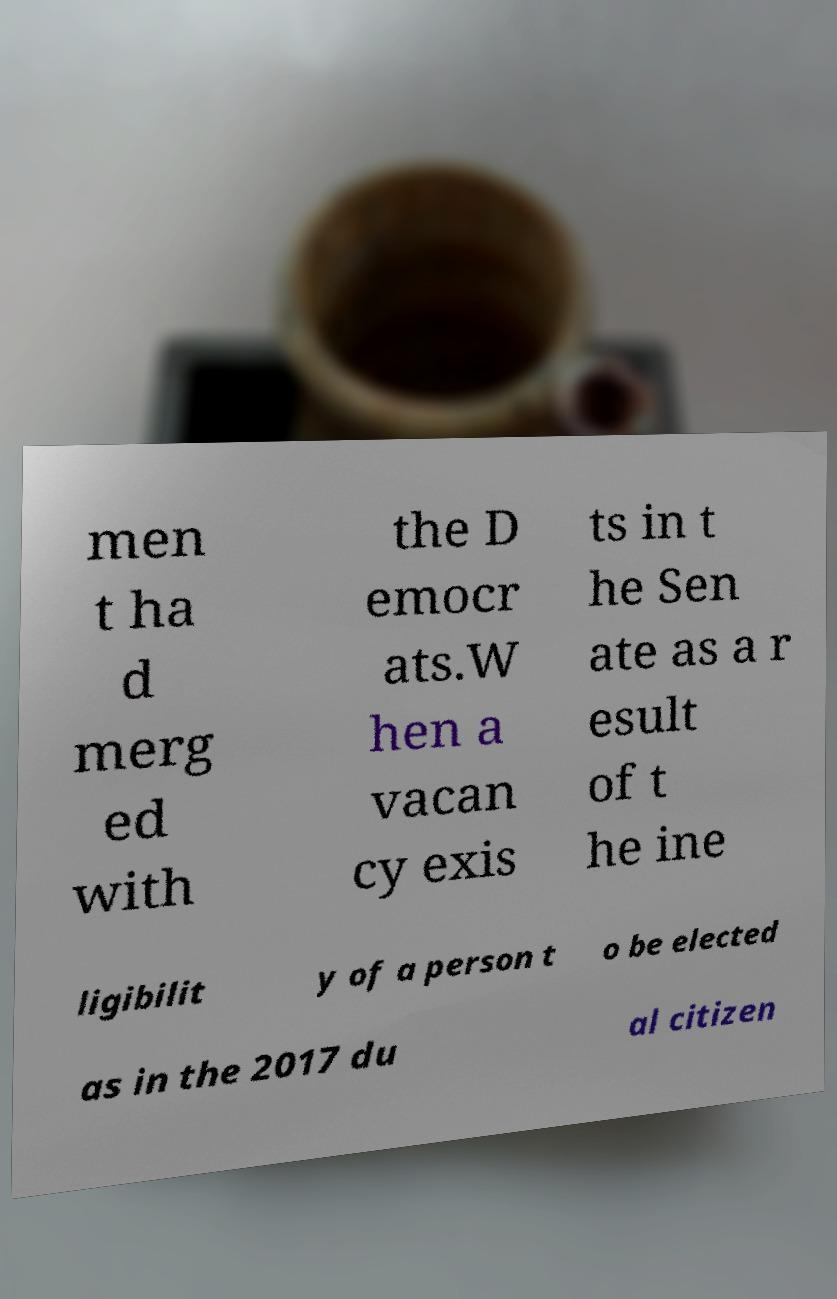What messages or text are displayed in this image? I need them in a readable, typed format. men t ha d merg ed with the D emocr ats.W hen a vacan cy exis ts in t he Sen ate as a r esult of t he ine ligibilit y of a person t o be elected as in the 2017 du al citizen 